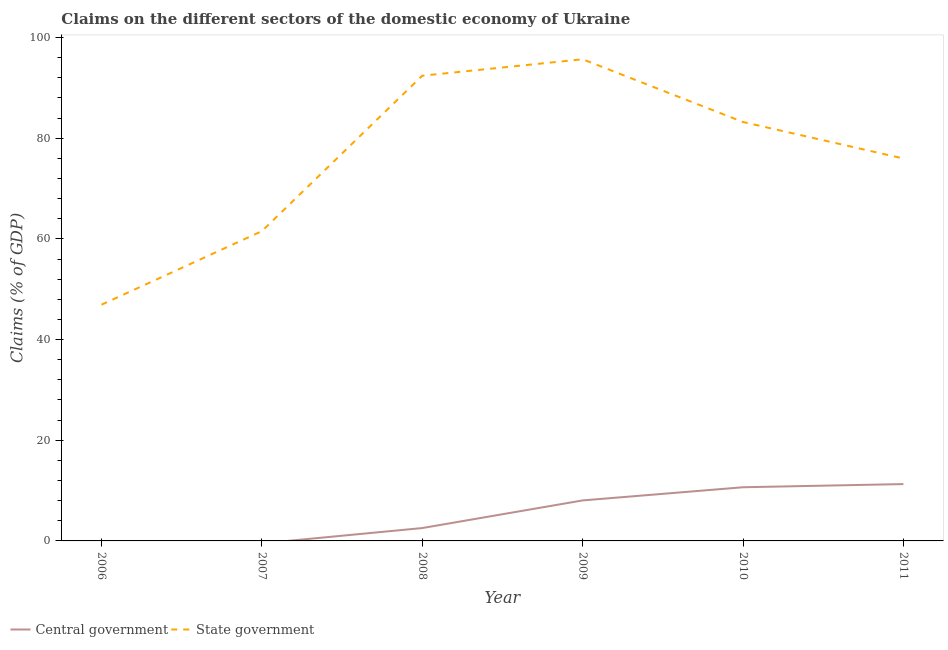How many different coloured lines are there?
Make the answer very short. 2. Is the number of lines equal to the number of legend labels?
Provide a succinct answer. No. What is the claims on state government in 2010?
Your response must be concise. 83.23. Across all years, what is the maximum claims on central government?
Give a very brief answer. 11.29. Across all years, what is the minimum claims on state government?
Keep it short and to the point. 46.93. In which year was the claims on central government maximum?
Make the answer very short. 2011. What is the total claims on state government in the graph?
Your response must be concise. 455.81. What is the difference between the claims on state government in 2006 and that in 2008?
Give a very brief answer. -45.49. What is the difference between the claims on state government in 2009 and the claims on central government in 2010?
Your answer should be very brief. 85.03. What is the average claims on state government per year?
Your response must be concise. 75.97. In the year 2008, what is the difference between the claims on state government and claims on central government?
Your answer should be very brief. 89.87. In how many years, is the claims on central government greater than 44 %?
Your answer should be very brief. 0. What is the ratio of the claims on state government in 2007 to that in 2008?
Offer a very short reply. 0.67. Is the difference between the claims on state government in 2009 and 2011 greater than the difference between the claims on central government in 2009 and 2011?
Your answer should be compact. Yes. What is the difference between the highest and the second highest claims on central government?
Ensure brevity in your answer.  0.63. What is the difference between the highest and the lowest claims on central government?
Your response must be concise. 11.29. In how many years, is the claims on state government greater than the average claims on state government taken over all years?
Offer a very short reply. 4. Is the claims on central government strictly greater than the claims on state government over the years?
Make the answer very short. No. How many lines are there?
Your answer should be very brief. 2. How many years are there in the graph?
Provide a short and direct response. 6. What is the difference between two consecutive major ticks on the Y-axis?
Provide a succinct answer. 20. What is the title of the graph?
Ensure brevity in your answer.  Claims on the different sectors of the domestic economy of Ukraine. What is the label or title of the X-axis?
Provide a succinct answer. Year. What is the label or title of the Y-axis?
Provide a short and direct response. Claims (% of GDP). What is the Claims (% of GDP) in State government in 2006?
Ensure brevity in your answer.  46.93. What is the Claims (% of GDP) in Central government in 2007?
Your answer should be compact. 0. What is the Claims (% of GDP) of State government in 2007?
Offer a very short reply. 61.54. What is the Claims (% of GDP) in Central government in 2008?
Provide a short and direct response. 2.56. What is the Claims (% of GDP) in State government in 2008?
Offer a very short reply. 92.43. What is the Claims (% of GDP) of Central government in 2009?
Your answer should be compact. 8.05. What is the Claims (% of GDP) of State government in 2009?
Your answer should be compact. 95.69. What is the Claims (% of GDP) in Central government in 2010?
Keep it short and to the point. 10.66. What is the Claims (% of GDP) of State government in 2010?
Keep it short and to the point. 83.23. What is the Claims (% of GDP) in Central government in 2011?
Ensure brevity in your answer.  11.29. What is the Claims (% of GDP) in State government in 2011?
Provide a short and direct response. 75.98. Across all years, what is the maximum Claims (% of GDP) in Central government?
Your response must be concise. 11.29. Across all years, what is the maximum Claims (% of GDP) of State government?
Provide a succinct answer. 95.69. Across all years, what is the minimum Claims (% of GDP) of State government?
Make the answer very short. 46.93. What is the total Claims (% of GDP) in Central government in the graph?
Provide a succinct answer. 32.56. What is the total Claims (% of GDP) of State government in the graph?
Give a very brief answer. 455.81. What is the difference between the Claims (% of GDP) in State government in 2006 and that in 2007?
Your response must be concise. -14.61. What is the difference between the Claims (% of GDP) in State government in 2006 and that in 2008?
Offer a terse response. -45.49. What is the difference between the Claims (% of GDP) in State government in 2006 and that in 2009?
Give a very brief answer. -48.76. What is the difference between the Claims (% of GDP) of State government in 2006 and that in 2010?
Ensure brevity in your answer.  -36.3. What is the difference between the Claims (% of GDP) of State government in 2006 and that in 2011?
Provide a succinct answer. -29.05. What is the difference between the Claims (% of GDP) of State government in 2007 and that in 2008?
Keep it short and to the point. -30.89. What is the difference between the Claims (% of GDP) of State government in 2007 and that in 2009?
Provide a succinct answer. -34.15. What is the difference between the Claims (% of GDP) of State government in 2007 and that in 2010?
Offer a very short reply. -21.69. What is the difference between the Claims (% of GDP) of State government in 2007 and that in 2011?
Your answer should be compact. -14.44. What is the difference between the Claims (% of GDP) of Central government in 2008 and that in 2009?
Your answer should be very brief. -5.49. What is the difference between the Claims (% of GDP) in State government in 2008 and that in 2009?
Provide a short and direct response. -3.27. What is the difference between the Claims (% of GDP) in Central government in 2008 and that in 2010?
Provide a short and direct response. -8.11. What is the difference between the Claims (% of GDP) of State government in 2008 and that in 2010?
Ensure brevity in your answer.  9.2. What is the difference between the Claims (% of GDP) of Central government in 2008 and that in 2011?
Provide a succinct answer. -8.74. What is the difference between the Claims (% of GDP) in State government in 2008 and that in 2011?
Your response must be concise. 16.45. What is the difference between the Claims (% of GDP) of Central government in 2009 and that in 2010?
Give a very brief answer. -2.62. What is the difference between the Claims (% of GDP) of State government in 2009 and that in 2010?
Offer a very short reply. 12.46. What is the difference between the Claims (% of GDP) of Central government in 2009 and that in 2011?
Provide a succinct answer. -3.25. What is the difference between the Claims (% of GDP) of State government in 2009 and that in 2011?
Keep it short and to the point. 19.71. What is the difference between the Claims (% of GDP) of Central government in 2010 and that in 2011?
Offer a terse response. -0.63. What is the difference between the Claims (% of GDP) in State government in 2010 and that in 2011?
Offer a terse response. 7.25. What is the difference between the Claims (% of GDP) in Central government in 2008 and the Claims (% of GDP) in State government in 2009?
Offer a very short reply. -93.14. What is the difference between the Claims (% of GDP) in Central government in 2008 and the Claims (% of GDP) in State government in 2010?
Give a very brief answer. -80.67. What is the difference between the Claims (% of GDP) of Central government in 2008 and the Claims (% of GDP) of State government in 2011?
Your response must be concise. -73.42. What is the difference between the Claims (% of GDP) of Central government in 2009 and the Claims (% of GDP) of State government in 2010?
Provide a short and direct response. -75.18. What is the difference between the Claims (% of GDP) in Central government in 2009 and the Claims (% of GDP) in State government in 2011?
Keep it short and to the point. -67.93. What is the difference between the Claims (% of GDP) of Central government in 2010 and the Claims (% of GDP) of State government in 2011?
Your answer should be compact. -65.32. What is the average Claims (% of GDP) in Central government per year?
Keep it short and to the point. 5.43. What is the average Claims (% of GDP) of State government per year?
Offer a terse response. 75.97. In the year 2008, what is the difference between the Claims (% of GDP) of Central government and Claims (% of GDP) of State government?
Keep it short and to the point. -89.87. In the year 2009, what is the difference between the Claims (% of GDP) in Central government and Claims (% of GDP) in State government?
Offer a very short reply. -87.65. In the year 2010, what is the difference between the Claims (% of GDP) of Central government and Claims (% of GDP) of State government?
Keep it short and to the point. -72.57. In the year 2011, what is the difference between the Claims (% of GDP) of Central government and Claims (% of GDP) of State government?
Offer a very short reply. -64.69. What is the ratio of the Claims (% of GDP) of State government in 2006 to that in 2007?
Your response must be concise. 0.76. What is the ratio of the Claims (% of GDP) in State government in 2006 to that in 2008?
Make the answer very short. 0.51. What is the ratio of the Claims (% of GDP) of State government in 2006 to that in 2009?
Provide a short and direct response. 0.49. What is the ratio of the Claims (% of GDP) in State government in 2006 to that in 2010?
Provide a short and direct response. 0.56. What is the ratio of the Claims (% of GDP) of State government in 2006 to that in 2011?
Make the answer very short. 0.62. What is the ratio of the Claims (% of GDP) of State government in 2007 to that in 2008?
Keep it short and to the point. 0.67. What is the ratio of the Claims (% of GDP) in State government in 2007 to that in 2009?
Your answer should be compact. 0.64. What is the ratio of the Claims (% of GDP) of State government in 2007 to that in 2010?
Provide a short and direct response. 0.74. What is the ratio of the Claims (% of GDP) in State government in 2007 to that in 2011?
Ensure brevity in your answer.  0.81. What is the ratio of the Claims (% of GDP) in Central government in 2008 to that in 2009?
Your response must be concise. 0.32. What is the ratio of the Claims (% of GDP) of State government in 2008 to that in 2009?
Your response must be concise. 0.97. What is the ratio of the Claims (% of GDP) of Central government in 2008 to that in 2010?
Provide a succinct answer. 0.24. What is the ratio of the Claims (% of GDP) in State government in 2008 to that in 2010?
Your answer should be compact. 1.11. What is the ratio of the Claims (% of GDP) of Central government in 2008 to that in 2011?
Give a very brief answer. 0.23. What is the ratio of the Claims (% of GDP) in State government in 2008 to that in 2011?
Your response must be concise. 1.22. What is the ratio of the Claims (% of GDP) of Central government in 2009 to that in 2010?
Your answer should be very brief. 0.75. What is the ratio of the Claims (% of GDP) in State government in 2009 to that in 2010?
Offer a very short reply. 1.15. What is the ratio of the Claims (% of GDP) in Central government in 2009 to that in 2011?
Provide a succinct answer. 0.71. What is the ratio of the Claims (% of GDP) of State government in 2009 to that in 2011?
Give a very brief answer. 1.26. What is the ratio of the Claims (% of GDP) in Central government in 2010 to that in 2011?
Offer a terse response. 0.94. What is the ratio of the Claims (% of GDP) of State government in 2010 to that in 2011?
Your response must be concise. 1.1. What is the difference between the highest and the second highest Claims (% of GDP) in Central government?
Ensure brevity in your answer.  0.63. What is the difference between the highest and the second highest Claims (% of GDP) of State government?
Provide a short and direct response. 3.27. What is the difference between the highest and the lowest Claims (% of GDP) of Central government?
Provide a succinct answer. 11.29. What is the difference between the highest and the lowest Claims (% of GDP) of State government?
Offer a very short reply. 48.76. 